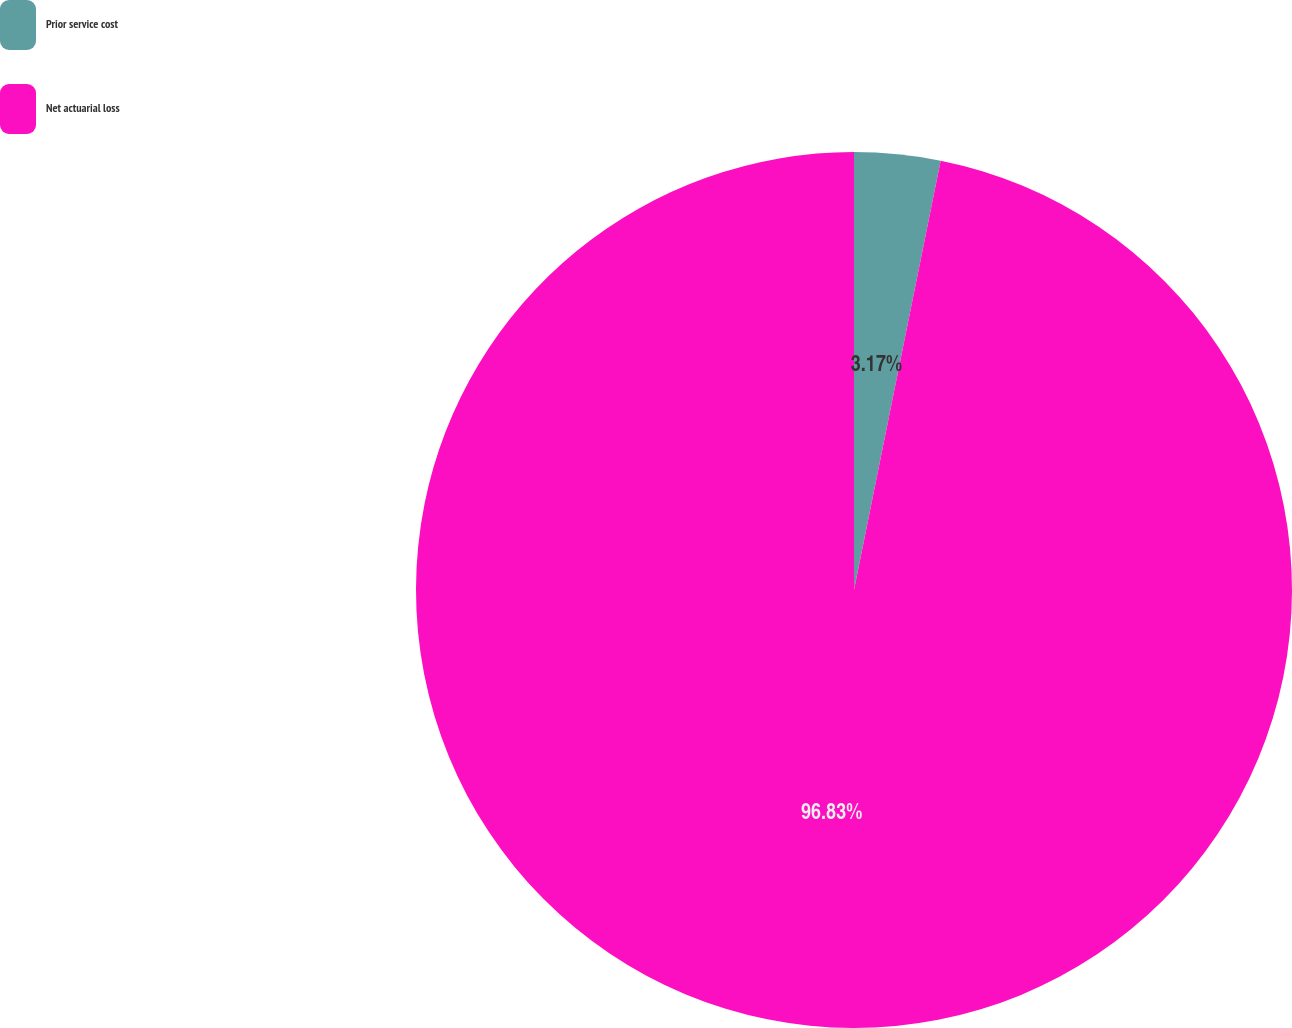Convert chart to OTSL. <chart><loc_0><loc_0><loc_500><loc_500><pie_chart><fcel>Prior service cost<fcel>Net actuarial loss<nl><fcel>3.17%<fcel>96.83%<nl></chart> 